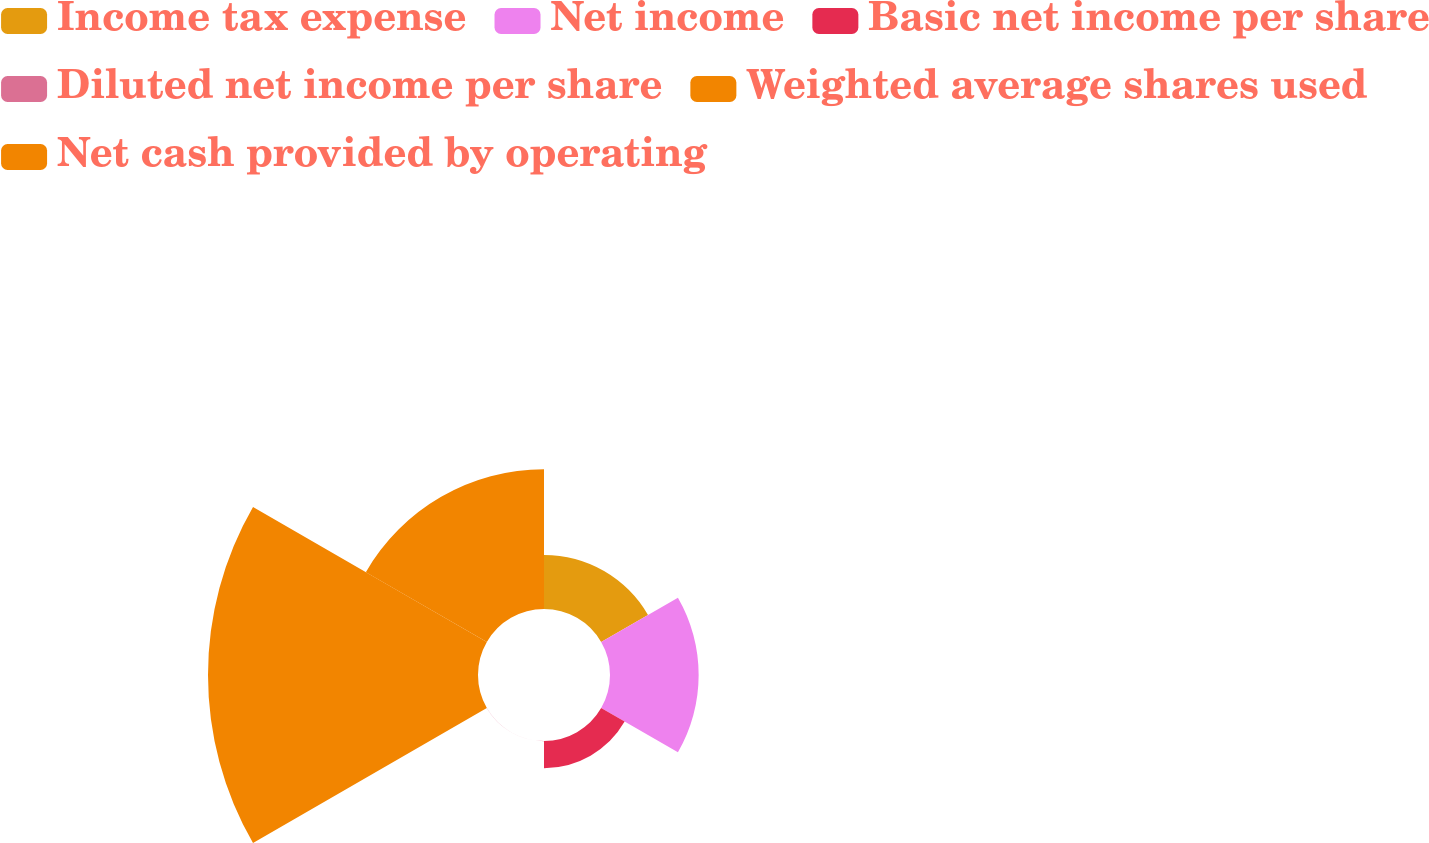Convert chart. <chart><loc_0><loc_0><loc_500><loc_500><pie_chart><fcel>Income tax expense<fcel>Net income<fcel>Basic net income per share<fcel>Diluted net income per share<fcel>Weighted average shares used<fcel>Net cash provided by operating<nl><fcel>9.33%<fcel>15.29%<fcel>4.68%<fcel>0.03%<fcel>46.57%<fcel>24.1%<nl></chart> 